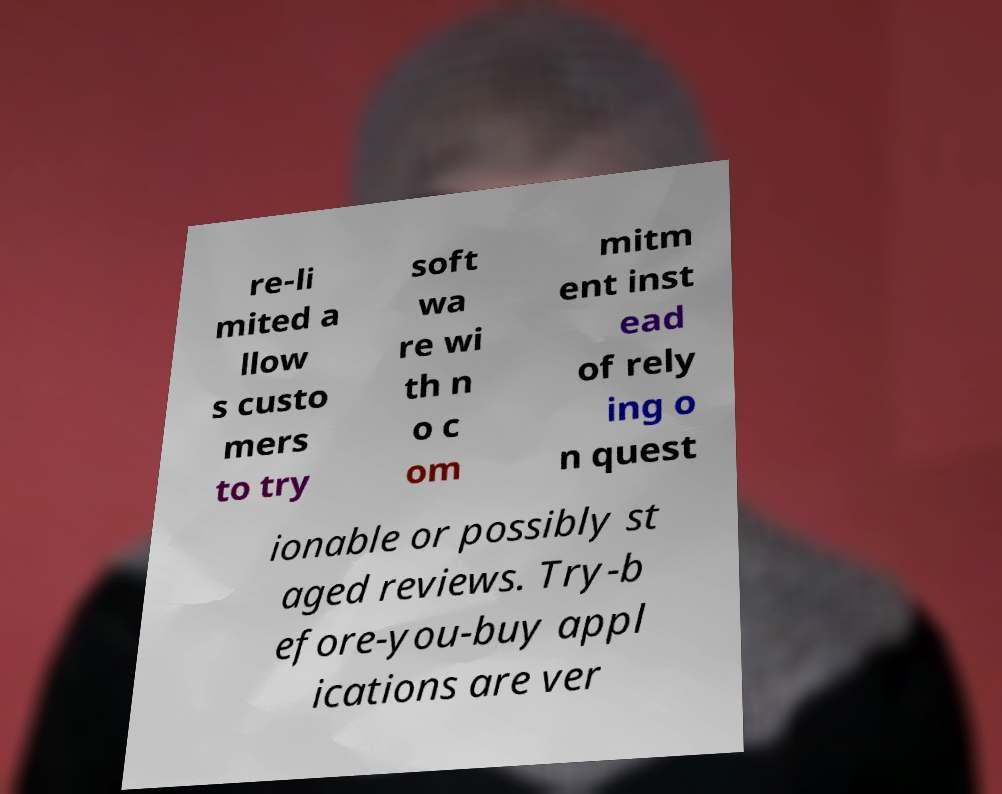What messages or text are displayed in this image? I need them in a readable, typed format. re-li mited a llow s custo mers to try soft wa re wi th n o c om mitm ent inst ead of rely ing o n quest ionable or possibly st aged reviews. Try-b efore-you-buy appl ications are ver 